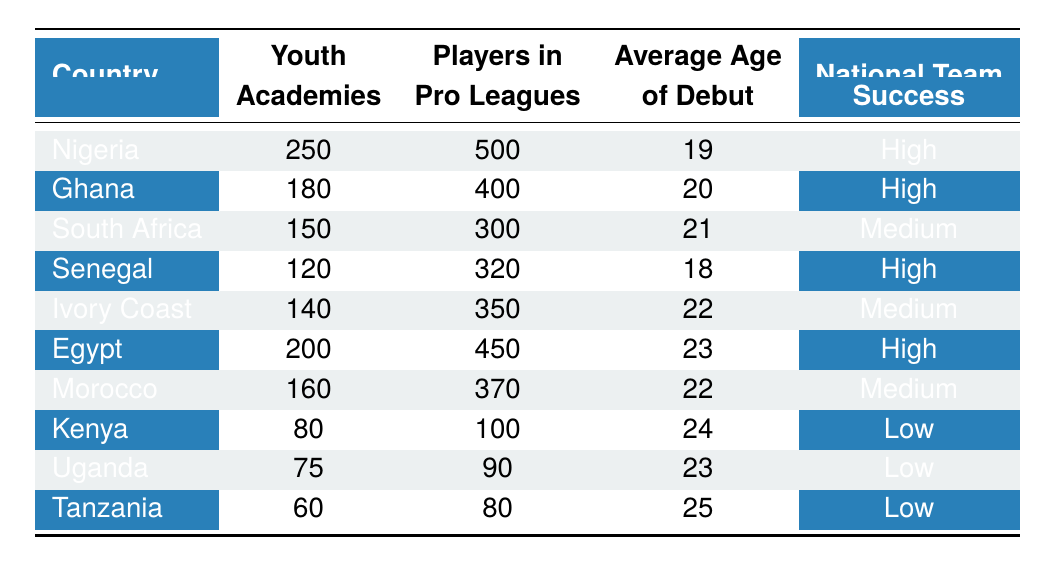What is the total number of youth academies in Nigeria and Ghana combined? To find the total, we add the number of youth academies from Nigeria (250) and Ghana (180). So, 250 + 180 = 430.
Answer: 430 Which country has the lowest number of players in professional leagues? By comparing the "Players in Pro Leagues" values, Kenya has the lowest with 100 players.
Answer: Kenya What is the average age of debut for players from Senegal? The average age of debut for Senegal is listed in the table as 18.
Answer: 18 Does Egypt have a high national team success? The table states that Egypt's national team success is classified as "High." So, yes, Egypt does have high national team success.
Answer: Yes How many more youth academies does Nigeria have compared to South Africa? To find the difference in youth academies, we subtract South Africa's total (150) from Nigeria's total (250). Thus, 250 - 150 = 100.
Answer: 100 Is the average age of debut lower for players in Senegal compared to those in South Africa? Senegal has an average age of debut of 18, while South Africa has an average age of 21. Since 18 is less than 21, this statement is true.
Answer: Yes Which country listed has the highest number of youth academies? The highest number of youth academies is found in Nigeria with 250 academies, according to the table.
Answer: Nigeria If we consider the three countries with the highest national team success, what is their average age of debut? The countries with high national team success are Nigeria (19), Ghana (20), and Senegal (18). The average is calculated as (19 + 20 + 18) / 3 = 19.
Answer: 19 